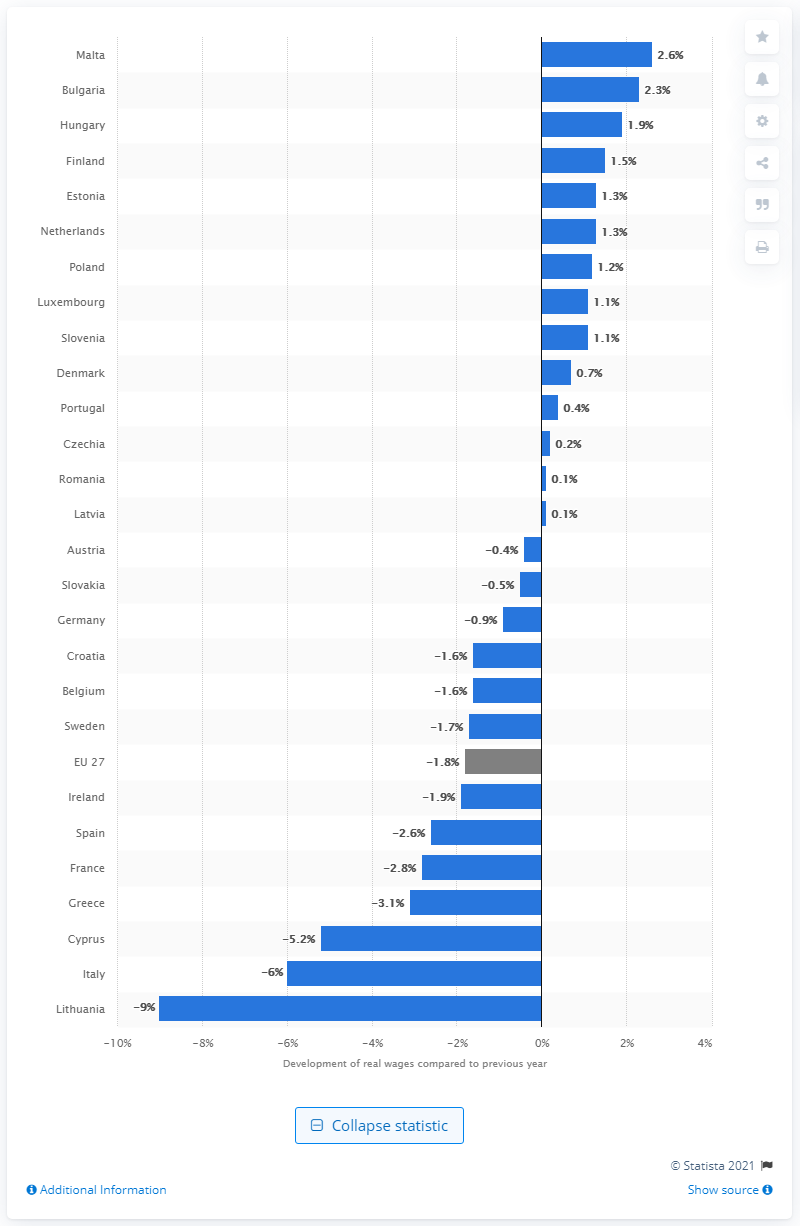Point out several critical features in this image. According to projections, real wages in Finland are expected to increase by 1.5% in 2020. 